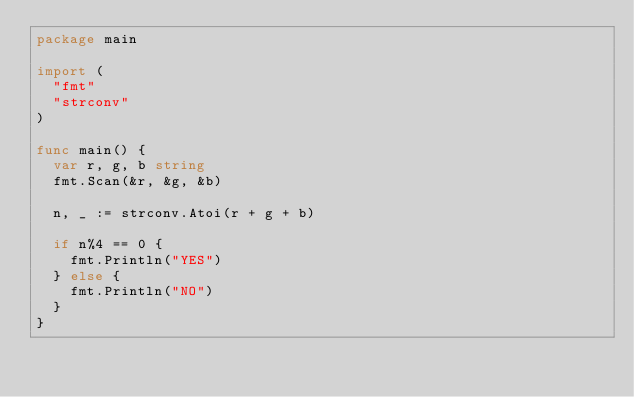Convert code to text. <code><loc_0><loc_0><loc_500><loc_500><_Go_>package main

import (
	"fmt"
	"strconv"
)

func main() {
	var r, g, b string
	fmt.Scan(&r, &g, &b)

	n, _ := strconv.Atoi(r + g + b)

	if n%4 == 0 {
		fmt.Println("YES")
	} else {
		fmt.Println("NO")
	}
}
</code> 